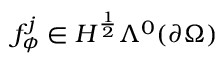<formula> <loc_0><loc_0><loc_500><loc_500>f _ { \phi } ^ { j } \in H ^ { \frac { 1 } { 2 } } \Lambda ^ { 0 } ( \partial \Omega )</formula> 